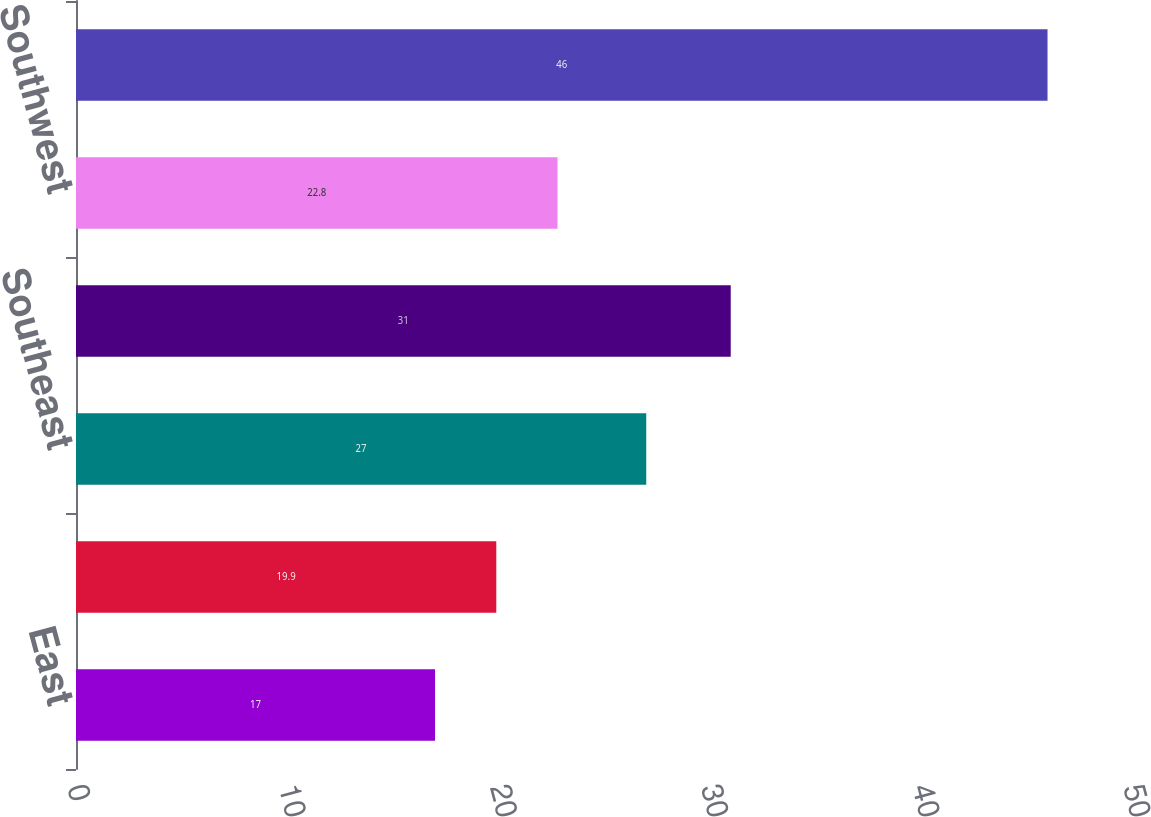<chart> <loc_0><loc_0><loc_500><loc_500><bar_chart><fcel>East<fcel>Midwest<fcel>Southeast<fcel>South Central<fcel>Southwest<fcel>West<nl><fcel>17<fcel>19.9<fcel>27<fcel>31<fcel>22.8<fcel>46<nl></chart> 